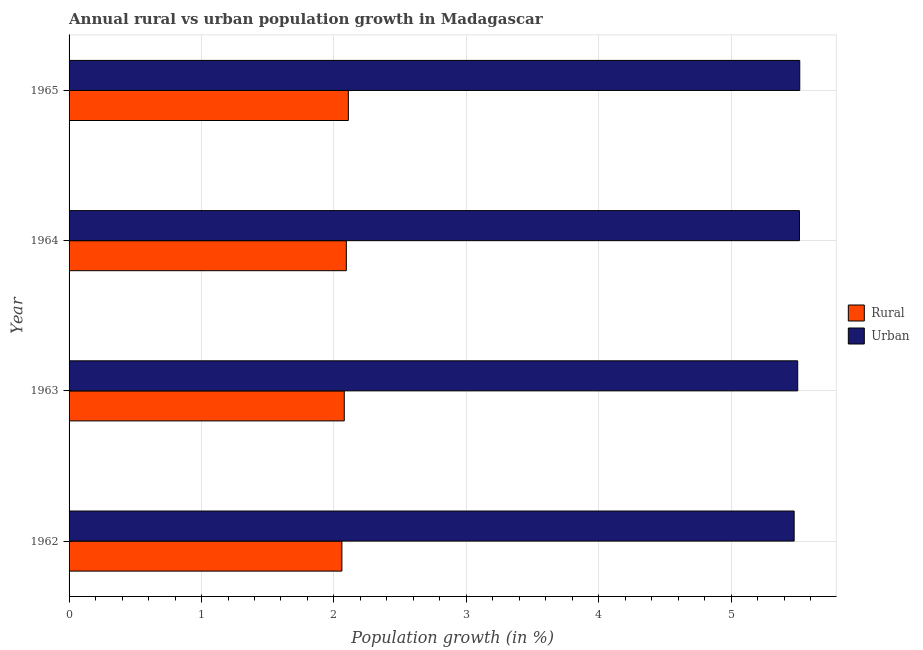How many different coloured bars are there?
Keep it short and to the point. 2. How many groups of bars are there?
Offer a terse response. 4. Are the number of bars per tick equal to the number of legend labels?
Your response must be concise. Yes. Are the number of bars on each tick of the Y-axis equal?
Give a very brief answer. Yes. How many bars are there on the 4th tick from the top?
Make the answer very short. 2. How many bars are there on the 2nd tick from the bottom?
Ensure brevity in your answer.  2. What is the label of the 3rd group of bars from the top?
Your answer should be very brief. 1963. What is the urban population growth in 1964?
Your response must be concise. 5.52. Across all years, what is the maximum rural population growth?
Keep it short and to the point. 2.11. Across all years, what is the minimum urban population growth?
Provide a short and direct response. 5.47. In which year was the rural population growth maximum?
Give a very brief answer. 1965. In which year was the rural population growth minimum?
Offer a terse response. 1962. What is the total rural population growth in the graph?
Your answer should be very brief. 8.34. What is the difference between the urban population growth in 1962 and that in 1963?
Your response must be concise. -0.03. What is the difference between the urban population growth in 1965 and the rural population growth in 1962?
Your answer should be compact. 3.46. What is the average urban population growth per year?
Your answer should be very brief. 5.5. In the year 1964, what is the difference between the rural population growth and urban population growth?
Your response must be concise. -3.42. In how many years, is the urban population growth greater than 5 %?
Offer a very short reply. 4. What is the ratio of the urban population growth in 1964 to that in 1965?
Your response must be concise. 1. Is the rural population growth in 1964 less than that in 1965?
Keep it short and to the point. Yes. What is the difference between the highest and the second highest rural population growth?
Offer a terse response. 0.01. What is the difference between the highest and the lowest urban population growth?
Ensure brevity in your answer.  0.04. In how many years, is the urban population growth greater than the average urban population growth taken over all years?
Ensure brevity in your answer.  2. What does the 1st bar from the top in 1965 represents?
Give a very brief answer. Urban . What does the 2nd bar from the bottom in 1964 represents?
Offer a very short reply. Urban . How many years are there in the graph?
Your response must be concise. 4. What is the difference between two consecutive major ticks on the X-axis?
Offer a very short reply. 1. Are the values on the major ticks of X-axis written in scientific E-notation?
Give a very brief answer. No. How are the legend labels stacked?
Keep it short and to the point. Vertical. What is the title of the graph?
Offer a terse response. Annual rural vs urban population growth in Madagascar. What is the label or title of the X-axis?
Keep it short and to the point. Population growth (in %). What is the Population growth (in %) in Rural in 1962?
Ensure brevity in your answer.  2.06. What is the Population growth (in %) in Urban  in 1962?
Provide a succinct answer. 5.47. What is the Population growth (in %) in Rural in 1963?
Offer a very short reply. 2.08. What is the Population growth (in %) in Urban  in 1963?
Offer a very short reply. 5.5. What is the Population growth (in %) in Rural in 1964?
Make the answer very short. 2.09. What is the Population growth (in %) in Urban  in 1964?
Provide a short and direct response. 5.52. What is the Population growth (in %) of Rural in 1965?
Make the answer very short. 2.11. What is the Population growth (in %) in Urban  in 1965?
Offer a terse response. 5.52. Across all years, what is the maximum Population growth (in %) of Rural?
Keep it short and to the point. 2.11. Across all years, what is the maximum Population growth (in %) of Urban ?
Keep it short and to the point. 5.52. Across all years, what is the minimum Population growth (in %) of Rural?
Offer a terse response. 2.06. Across all years, what is the minimum Population growth (in %) of Urban ?
Your answer should be compact. 5.47. What is the total Population growth (in %) in Rural in the graph?
Ensure brevity in your answer.  8.34. What is the total Population growth (in %) of Urban  in the graph?
Your answer should be very brief. 22.01. What is the difference between the Population growth (in %) of Rural in 1962 and that in 1963?
Make the answer very short. -0.02. What is the difference between the Population growth (in %) of Urban  in 1962 and that in 1963?
Ensure brevity in your answer.  -0.03. What is the difference between the Population growth (in %) in Rural in 1962 and that in 1964?
Provide a short and direct response. -0.03. What is the difference between the Population growth (in %) of Urban  in 1962 and that in 1964?
Give a very brief answer. -0.04. What is the difference between the Population growth (in %) in Rural in 1962 and that in 1965?
Your response must be concise. -0.05. What is the difference between the Population growth (in %) in Urban  in 1962 and that in 1965?
Ensure brevity in your answer.  -0.04. What is the difference between the Population growth (in %) in Rural in 1963 and that in 1964?
Keep it short and to the point. -0.02. What is the difference between the Population growth (in %) of Urban  in 1963 and that in 1964?
Your answer should be very brief. -0.01. What is the difference between the Population growth (in %) of Rural in 1963 and that in 1965?
Your response must be concise. -0.03. What is the difference between the Population growth (in %) in Urban  in 1963 and that in 1965?
Make the answer very short. -0.02. What is the difference between the Population growth (in %) in Rural in 1964 and that in 1965?
Offer a terse response. -0.02. What is the difference between the Population growth (in %) of Urban  in 1964 and that in 1965?
Your answer should be compact. -0. What is the difference between the Population growth (in %) in Rural in 1962 and the Population growth (in %) in Urban  in 1963?
Your answer should be very brief. -3.44. What is the difference between the Population growth (in %) of Rural in 1962 and the Population growth (in %) of Urban  in 1964?
Your response must be concise. -3.46. What is the difference between the Population growth (in %) of Rural in 1962 and the Population growth (in %) of Urban  in 1965?
Keep it short and to the point. -3.46. What is the difference between the Population growth (in %) in Rural in 1963 and the Population growth (in %) in Urban  in 1964?
Your answer should be very brief. -3.44. What is the difference between the Population growth (in %) in Rural in 1963 and the Population growth (in %) in Urban  in 1965?
Make the answer very short. -3.44. What is the difference between the Population growth (in %) of Rural in 1964 and the Population growth (in %) of Urban  in 1965?
Provide a succinct answer. -3.42. What is the average Population growth (in %) of Rural per year?
Offer a terse response. 2.09. What is the average Population growth (in %) of Urban  per year?
Offer a very short reply. 5.5. In the year 1962, what is the difference between the Population growth (in %) of Rural and Population growth (in %) of Urban ?
Your answer should be very brief. -3.41. In the year 1963, what is the difference between the Population growth (in %) of Rural and Population growth (in %) of Urban ?
Make the answer very short. -3.42. In the year 1964, what is the difference between the Population growth (in %) of Rural and Population growth (in %) of Urban ?
Offer a very short reply. -3.42. In the year 1965, what is the difference between the Population growth (in %) in Rural and Population growth (in %) in Urban ?
Provide a succinct answer. -3.41. What is the ratio of the Population growth (in %) in Rural in 1962 to that in 1963?
Make the answer very short. 0.99. What is the ratio of the Population growth (in %) in Urban  in 1962 to that in 1963?
Make the answer very short. 1. What is the ratio of the Population growth (in %) of Rural in 1962 to that in 1964?
Offer a terse response. 0.98. What is the ratio of the Population growth (in %) of Urban  in 1962 to that in 1964?
Offer a very short reply. 0.99. What is the ratio of the Population growth (in %) in Rural in 1963 to that in 1964?
Make the answer very short. 0.99. What is the ratio of the Population growth (in %) of Urban  in 1963 to that in 1964?
Your answer should be very brief. 1. What is the ratio of the Population growth (in %) in Rural in 1963 to that in 1965?
Ensure brevity in your answer.  0.99. What is the ratio of the Population growth (in %) of Urban  in 1963 to that in 1965?
Offer a terse response. 1. What is the ratio of the Population growth (in %) in Rural in 1964 to that in 1965?
Provide a short and direct response. 0.99. What is the difference between the highest and the second highest Population growth (in %) of Rural?
Make the answer very short. 0.02. What is the difference between the highest and the second highest Population growth (in %) of Urban ?
Make the answer very short. 0. What is the difference between the highest and the lowest Population growth (in %) of Rural?
Your answer should be compact. 0.05. What is the difference between the highest and the lowest Population growth (in %) of Urban ?
Your response must be concise. 0.04. 